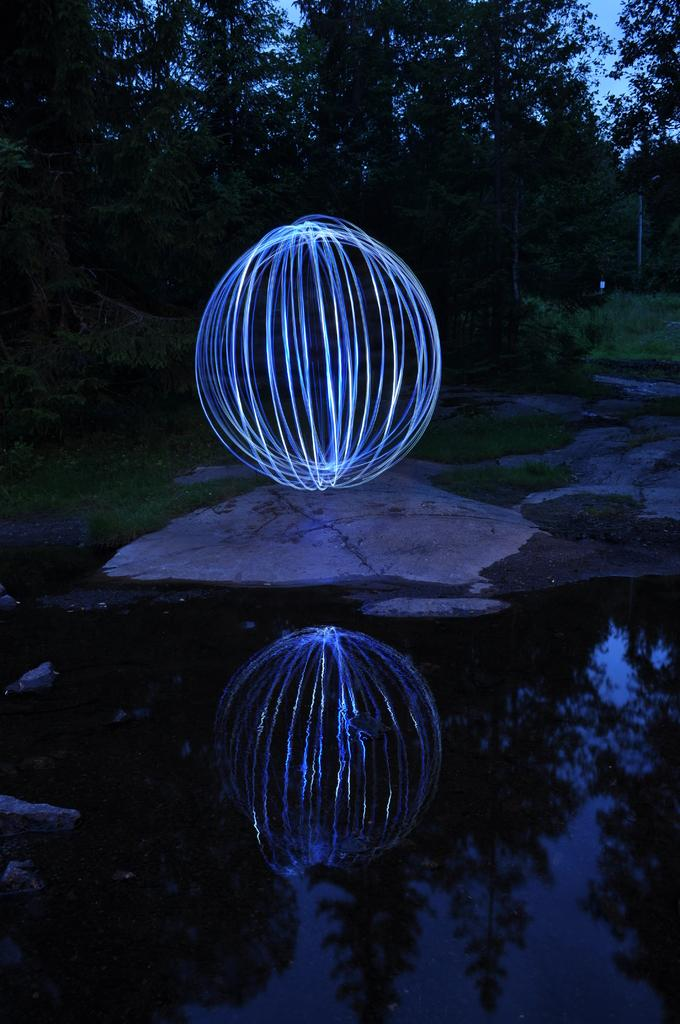What is the shape of the object on the floor in the image? The object on the floor is circular. What type of natural elements can be seen in the image? Trees and water are visible in the image. What part of the natural environment is visible in the image? Some part of the sky is visible in the image. What is the condition of the burst in the image? There is no burst present in the image. What does the smell of the trees in the image resemble? The image does not provide information about the smell of the trees, as it is a visual medium. 